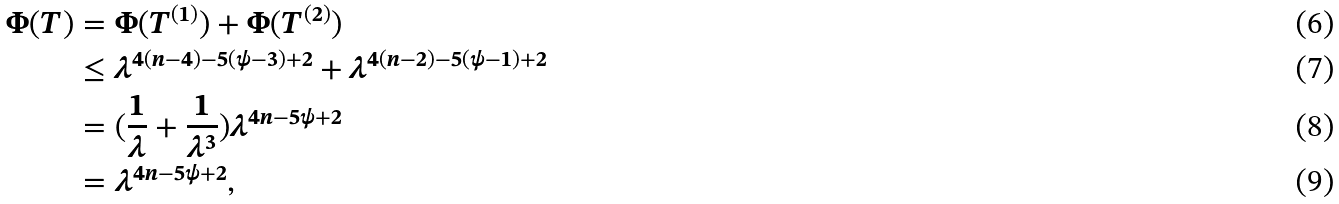<formula> <loc_0><loc_0><loc_500><loc_500>\Phi ( T ) & = \Phi ( T ^ { ( 1 ) } ) + \Phi ( T ^ { ( 2 ) } ) \\ & \leq \lambda ^ { 4 ( n - 4 ) - 5 ( \psi - 3 ) + 2 } + \lambda ^ { 4 ( n - 2 ) - 5 ( \psi - 1 ) + 2 } \\ & = ( \frac { 1 } { \lambda } + \frac { 1 } { \lambda ^ { 3 } } ) \lambda ^ { 4 n - 5 \psi + 2 } \\ & = \lambda ^ { 4 n - 5 \psi + 2 } ,</formula> 